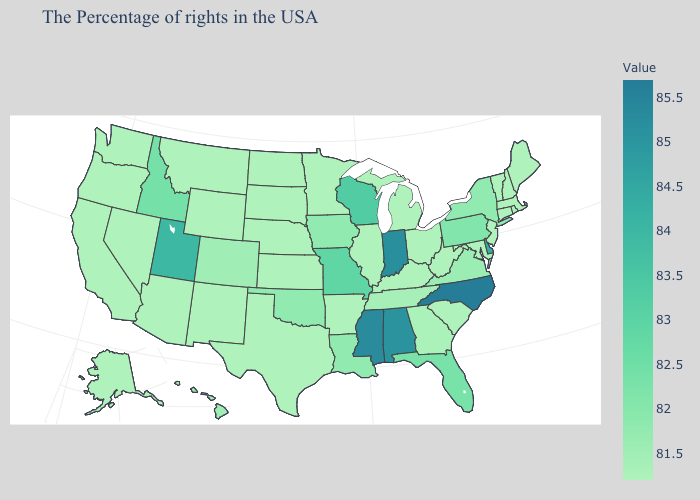Is the legend a continuous bar?
Be succinct. Yes. Which states have the lowest value in the USA?
Be succinct. Maine, Massachusetts, Rhode Island, New Hampshire, Vermont, Connecticut, New Jersey, Maryland, South Carolina, West Virginia, Ohio, Michigan, Kentucky, Illinois, Arkansas, Minnesota, Kansas, Nebraska, Texas, South Dakota, North Dakota, Wyoming, New Mexico, Montana, Arizona, Nevada, California, Washington, Oregon, Alaska. Does Colorado have the lowest value in the West?
Keep it brief. No. Does Mississippi have a lower value than Nebraska?
Write a very short answer. No. Which states have the highest value in the USA?
Keep it brief. North Carolina. Does Kansas have the highest value in the MidWest?
Concise answer only. No. 